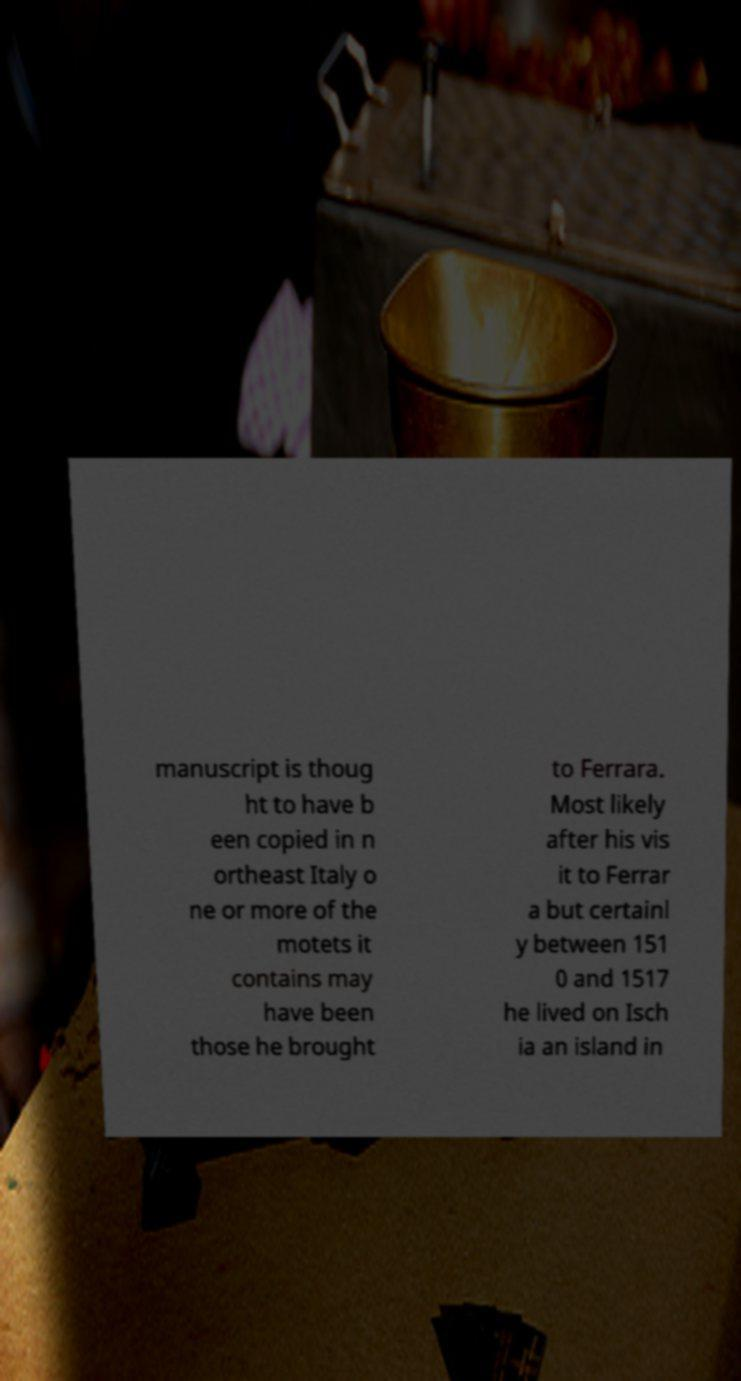For documentation purposes, I need the text within this image transcribed. Could you provide that? manuscript is thoug ht to have b een copied in n ortheast Italy o ne or more of the motets it contains may have been those he brought to Ferrara. Most likely after his vis it to Ferrar a but certainl y between 151 0 and 1517 he lived on Isch ia an island in 